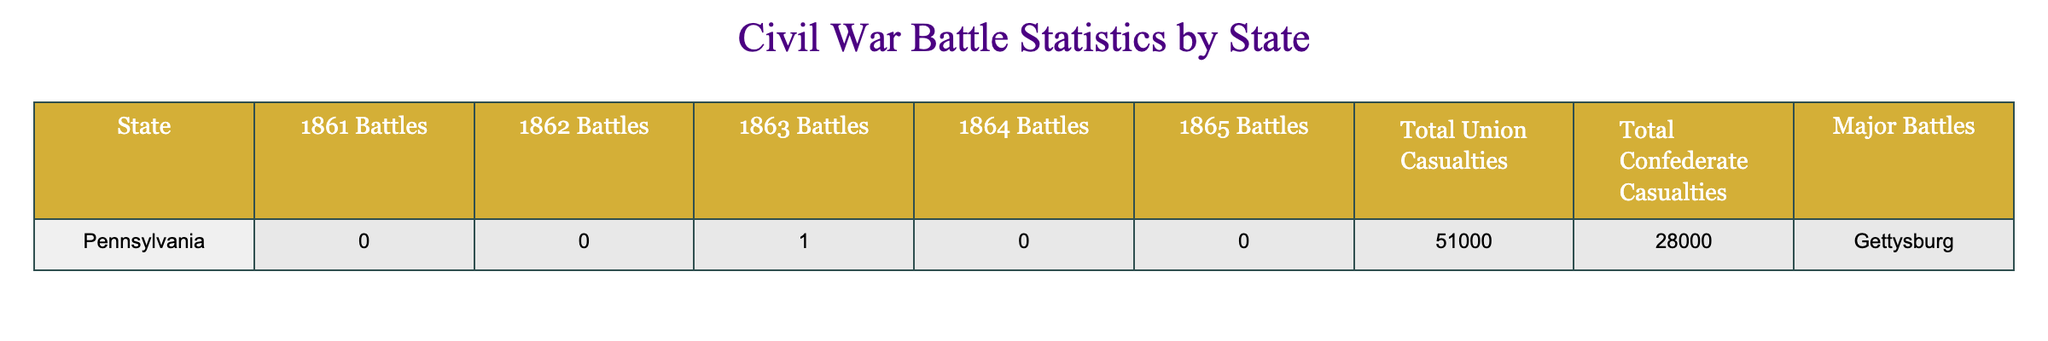What was the total number of battles fought in Pennsylvania during 1863? The table shows that in 1863, Pennsylvania had 1 battle listed.
Answer: 1 What are the total Union casualties for Pennsylvania? The table states that total Union casualties for Pennsylvania were 51,000.
Answer: 51,000 Did Pennsylvania have any battles in 1861? The table shows that there were 0 battles in Pennsylvania during 1861.
Answer: No What is the difference in total casualties between Union and Confederate forces in Pennsylvania? The table indicates 51,000 Union casualties and 28,000 Confederate casualties. The difference is 51,000 - 28,000 = 23,000.
Answer: 23,000 What is the total number of battles Pennsylvania fought from 1861 to 1865? Adding the battles from each year: 0 (1861) + 0 (1862) + 1 (1863) + 0 (1864) + 0 (1865) totals to 1 battle.
Answer: 1 Which year had the most battles for Pennsylvania based on the table? The table lists the number of battles per year, and 1863 is the only year with battles, totaling 1 battle.
Answer: 1863 How many total casualties were there for both Union and Confederate forces in Pennsylvania? The total is found by adding Union casualties (51,000) and Confederate casualties (28,000), resulting in 51,000 + 28,000 = 79,000.
Answer: 79,000 Which major battle is listed for Pennsylvania, and in which year did it occur? The table specifies the major battle in Pennsylvania as Gettysburg, which occurred in 1863.
Answer: Gettysburg in 1863 What is the ratio of Union casualties to Confederate casualties in Pennsylvania? The table shows 51,000 Union and 28,000 Confederate casualties. The ratio is calculated as 51,000:28,000, which simplifies to approximately 1.82:1.
Answer: Approximately 1.82:1 In which year did Pennsylvania not engage in any battles based on the data? The table states that Pennsylvania had 0 battles in 1861, 1862, 1864, and 1865, indicating multiple years without engagement.
Answer: 1861, 1862, 1864, 1865 